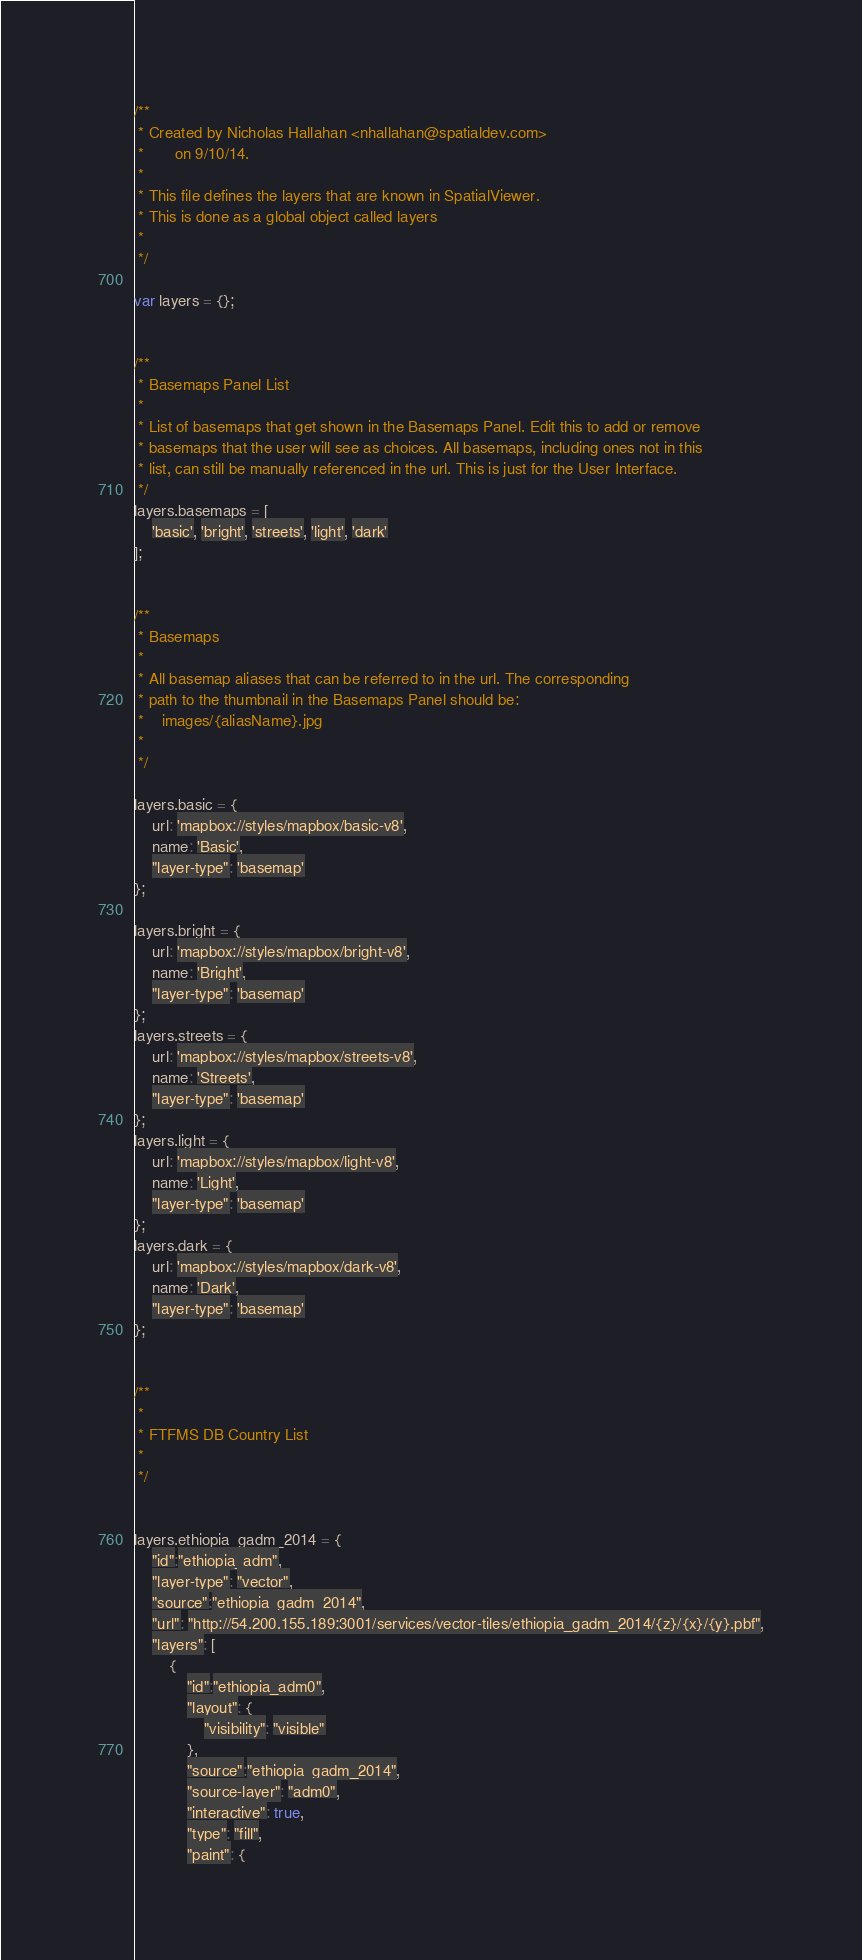<code> <loc_0><loc_0><loc_500><loc_500><_JavaScript_>/**
 * Created by Nicholas Hallahan <nhallahan@spatialdev.com>
 *       on 9/10/14.
 *
 * This file defines the layers that are known in SpatialViewer.
 * This is done as a global object called layers
 *
 */

var layers = {};


/**
 * Basemaps Panel List
 *
 * List of basemaps that get shown in the Basemaps Panel. Edit this to add or remove
 * basemaps that the user will see as choices. All basemaps, including ones not in this
 * list, can still be manually referenced in the url. This is just for the User Interface.
 */
layers.basemaps = [
    'basic', 'bright', 'streets', 'light', 'dark'
];


/**
 * Basemaps
 *
 * All basemap aliases that can be referred to in the url. The corresponding
 * path to the thumbnail in the Basemaps Panel should be:
 *    images/{aliasName}.jpg
 *
 */

layers.basic = {
    url: 'mapbox://styles/mapbox/basic-v8',
    name: 'Basic',
    "layer-type": 'basemap'
};

layers.bright = {
    url: 'mapbox://styles/mapbox/bright-v8',
    name: 'Bright',
    "layer-type": 'basemap'
};
layers.streets = {
    url: 'mapbox://styles/mapbox/streets-v8',
    name: 'Streets',
    "layer-type": 'basemap'
};
layers.light = {
    url: 'mapbox://styles/mapbox/light-v8',
    name: 'Light',
    "layer-type": 'basemap'
};
layers.dark = {
    url: 'mapbox://styles/mapbox/dark-v8',
    name: 'Dark',
    "layer-type": 'basemap'
};


/**
 *
 * FTFMS DB Country List
 *
 */


layers.ethiopia_gadm_2014 = {
    "id":"ethiopia_adm",
    "layer-type": "vector",
    "source":"ethiopia_gadm_2014",
    "url": "http://54.200.155.189:3001/services/vector-tiles/ethiopia_gadm_2014/{z}/{x}/{y}.pbf",
    "layers": [
        {
            "id":"ethiopia_adm0",
            "layout": {
                "visibility": "visible"
            },
            "source":"ethiopia_gadm_2014",
            "source-layer": "adm0",
            "interactive": true,
            "type": "fill",
            "paint": {</code> 